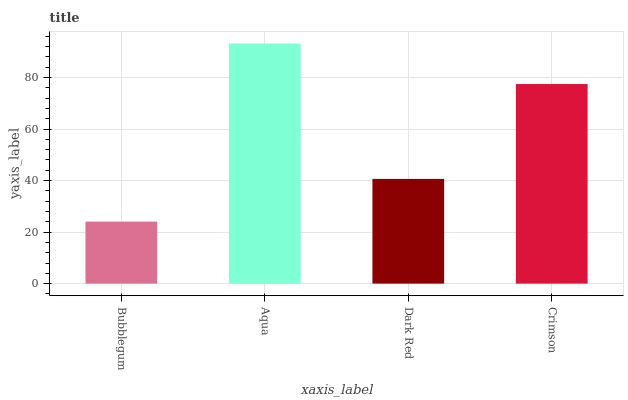Is Bubblegum the minimum?
Answer yes or no. Yes. Is Aqua the maximum?
Answer yes or no. Yes. Is Dark Red the minimum?
Answer yes or no. No. Is Dark Red the maximum?
Answer yes or no. No. Is Aqua greater than Dark Red?
Answer yes or no. Yes. Is Dark Red less than Aqua?
Answer yes or no. Yes. Is Dark Red greater than Aqua?
Answer yes or no. No. Is Aqua less than Dark Red?
Answer yes or no. No. Is Crimson the high median?
Answer yes or no. Yes. Is Dark Red the low median?
Answer yes or no. Yes. Is Bubblegum the high median?
Answer yes or no. No. Is Bubblegum the low median?
Answer yes or no. No. 